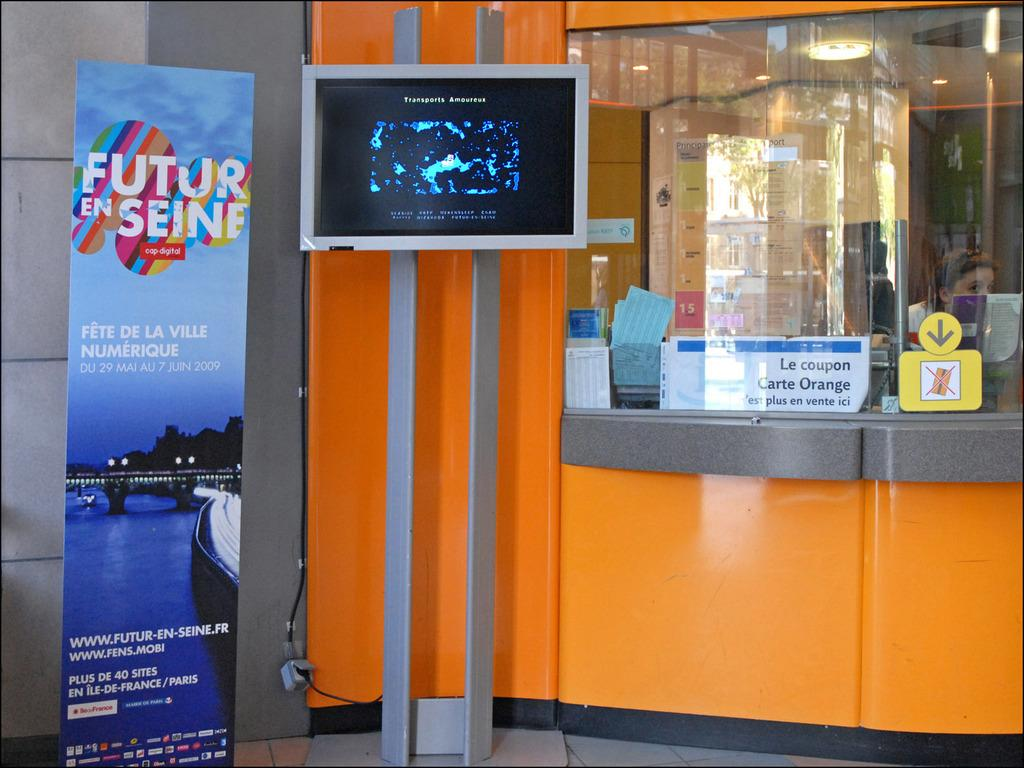Provide a one-sentence caption for the provided image. An orange booth has a sign next to it that says Future En Seine. 